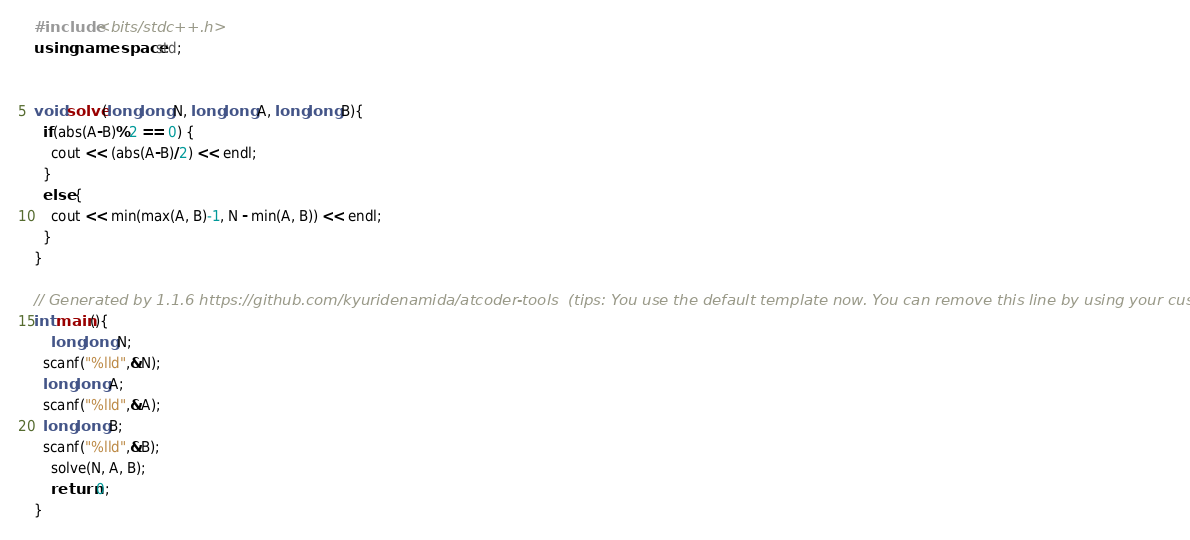<code> <loc_0><loc_0><loc_500><loc_500><_C++_>#include <bits/stdc++.h>
using namespace std;


void solve(long long N, long long A, long long B){
  if(abs(A-B)%2 == 0) {
    cout << (abs(A-B)/2) << endl;
  }
  else {
    cout << min(max(A, B)-1, N - min(A, B)) << endl;
  }
}

// Generated by 1.1.6 https://github.com/kyuridenamida/atcoder-tools  (tips: You use the default template now. You can remove this line by using your custom template)
int main(){
    long long N;
  scanf("%lld",&N);
  long long A;
  scanf("%lld",&A);
  long long B;
  scanf("%lld",&B);
    solve(N, A, B);
    return 0;
}
</code> 